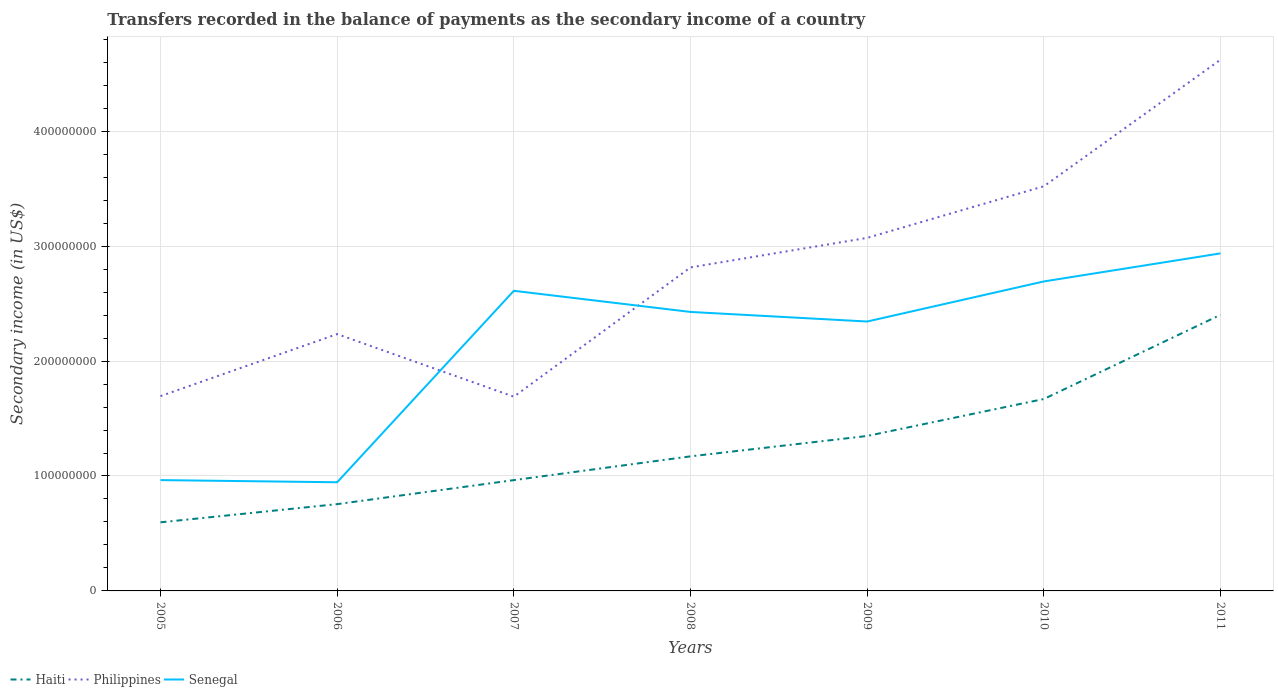Across all years, what is the maximum secondary income of in Senegal?
Give a very brief answer. 9.45e+07. What is the total secondary income of in Senegal in the graph?
Provide a short and direct response. -2.44e+07. What is the difference between the highest and the second highest secondary income of in Haiti?
Make the answer very short. 1.81e+08. What is the difference between the highest and the lowest secondary income of in Senegal?
Ensure brevity in your answer.  5. Is the secondary income of in Haiti strictly greater than the secondary income of in Senegal over the years?
Your response must be concise. Yes. How many years are there in the graph?
Give a very brief answer. 7. How many legend labels are there?
Make the answer very short. 3. How are the legend labels stacked?
Ensure brevity in your answer.  Horizontal. What is the title of the graph?
Provide a short and direct response. Transfers recorded in the balance of payments as the secondary income of a country. What is the label or title of the Y-axis?
Ensure brevity in your answer.  Secondary income (in US$). What is the Secondary income (in US$) in Haiti in 2005?
Make the answer very short. 5.97e+07. What is the Secondary income (in US$) of Philippines in 2005?
Provide a short and direct response. 1.69e+08. What is the Secondary income (in US$) in Senegal in 2005?
Provide a succinct answer. 9.64e+07. What is the Secondary income (in US$) of Haiti in 2006?
Offer a terse response. 7.55e+07. What is the Secondary income (in US$) of Philippines in 2006?
Make the answer very short. 2.23e+08. What is the Secondary income (in US$) of Senegal in 2006?
Give a very brief answer. 9.45e+07. What is the Secondary income (in US$) in Haiti in 2007?
Ensure brevity in your answer.  9.64e+07. What is the Secondary income (in US$) in Philippines in 2007?
Provide a succinct answer. 1.69e+08. What is the Secondary income (in US$) of Senegal in 2007?
Make the answer very short. 2.61e+08. What is the Secondary income (in US$) in Haiti in 2008?
Ensure brevity in your answer.  1.17e+08. What is the Secondary income (in US$) in Philippines in 2008?
Ensure brevity in your answer.  2.81e+08. What is the Secondary income (in US$) in Senegal in 2008?
Make the answer very short. 2.43e+08. What is the Secondary income (in US$) of Haiti in 2009?
Offer a very short reply. 1.35e+08. What is the Secondary income (in US$) of Philippines in 2009?
Provide a succinct answer. 3.07e+08. What is the Secondary income (in US$) of Senegal in 2009?
Provide a short and direct response. 2.34e+08. What is the Secondary income (in US$) of Haiti in 2010?
Provide a succinct answer. 1.67e+08. What is the Secondary income (in US$) in Philippines in 2010?
Your answer should be very brief. 3.52e+08. What is the Secondary income (in US$) of Senegal in 2010?
Provide a short and direct response. 2.69e+08. What is the Secondary income (in US$) in Haiti in 2011?
Offer a terse response. 2.40e+08. What is the Secondary income (in US$) in Philippines in 2011?
Your response must be concise. 4.62e+08. What is the Secondary income (in US$) of Senegal in 2011?
Your answer should be very brief. 2.94e+08. Across all years, what is the maximum Secondary income (in US$) of Haiti?
Your answer should be very brief. 2.40e+08. Across all years, what is the maximum Secondary income (in US$) of Philippines?
Your response must be concise. 4.62e+08. Across all years, what is the maximum Secondary income (in US$) of Senegal?
Make the answer very short. 2.94e+08. Across all years, what is the minimum Secondary income (in US$) of Haiti?
Provide a succinct answer. 5.97e+07. Across all years, what is the minimum Secondary income (in US$) of Philippines?
Your answer should be very brief. 1.69e+08. Across all years, what is the minimum Secondary income (in US$) in Senegal?
Give a very brief answer. 9.45e+07. What is the total Secondary income (in US$) of Haiti in the graph?
Give a very brief answer. 8.91e+08. What is the total Secondary income (in US$) in Philippines in the graph?
Ensure brevity in your answer.  1.96e+09. What is the total Secondary income (in US$) in Senegal in the graph?
Make the answer very short. 1.49e+09. What is the difference between the Secondary income (in US$) in Haiti in 2005 and that in 2006?
Your response must be concise. -1.58e+07. What is the difference between the Secondary income (in US$) in Philippines in 2005 and that in 2006?
Your answer should be very brief. -5.40e+07. What is the difference between the Secondary income (in US$) of Senegal in 2005 and that in 2006?
Give a very brief answer. 1.89e+06. What is the difference between the Secondary income (in US$) of Haiti in 2005 and that in 2007?
Make the answer very short. -3.67e+07. What is the difference between the Secondary income (in US$) of Philippines in 2005 and that in 2007?
Your answer should be very brief. 4.85e+05. What is the difference between the Secondary income (in US$) of Senegal in 2005 and that in 2007?
Offer a terse response. -1.65e+08. What is the difference between the Secondary income (in US$) in Haiti in 2005 and that in 2008?
Your response must be concise. -5.74e+07. What is the difference between the Secondary income (in US$) in Philippines in 2005 and that in 2008?
Offer a very short reply. -1.12e+08. What is the difference between the Secondary income (in US$) of Senegal in 2005 and that in 2008?
Offer a terse response. -1.46e+08. What is the difference between the Secondary income (in US$) in Haiti in 2005 and that in 2009?
Give a very brief answer. -7.51e+07. What is the difference between the Secondary income (in US$) of Philippines in 2005 and that in 2009?
Ensure brevity in your answer.  -1.38e+08. What is the difference between the Secondary income (in US$) of Senegal in 2005 and that in 2009?
Give a very brief answer. -1.38e+08. What is the difference between the Secondary income (in US$) in Haiti in 2005 and that in 2010?
Offer a very short reply. -1.07e+08. What is the difference between the Secondary income (in US$) of Philippines in 2005 and that in 2010?
Ensure brevity in your answer.  -1.83e+08. What is the difference between the Secondary income (in US$) in Senegal in 2005 and that in 2010?
Offer a very short reply. -1.73e+08. What is the difference between the Secondary income (in US$) in Haiti in 2005 and that in 2011?
Ensure brevity in your answer.  -1.81e+08. What is the difference between the Secondary income (in US$) of Philippines in 2005 and that in 2011?
Offer a very short reply. -2.93e+08. What is the difference between the Secondary income (in US$) of Senegal in 2005 and that in 2011?
Ensure brevity in your answer.  -1.97e+08. What is the difference between the Secondary income (in US$) of Haiti in 2006 and that in 2007?
Ensure brevity in your answer.  -2.09e+07. What is the difference between the Secondary income (in US$) of Philippines in 2006 and that in 2007?
Your response must be concise. 5.45e+07. What is the difference between the Secondary income (in US$) of Senegal in 2006 and that in 2007?
Your answer should be compact. -1.67e+08. What is the difference between the Secondary income (in US$) in Haiti in 2006 and that in 2008?
Offer a very short reply. -4.16e+07. What is the difference between the Secondary income (in US$) of Philippines in 2006 and that in 2008?
Your answer should be very brief. -5.80e+07. What is the difference between the Secondary income (in US$) of Senegal in 2006 and that in 2008?
Offer a very short reply. -1.48e+08. What is the difference between the Secondary income (in US$) in Haiti in 2006 and that in 2009?
Offer a very short reply. -5.93e+07. What is the difference between the Secondary income (in US$) of Philippines in 2006 and that in 2009?
Give a very brief answer. -8.37e+07. What is the difference between the Secondary income (in US$) of Senegal in 2006 and that in 2009?
Your response must be concise. -1.40e+08. What is the difference between the Secondary income (in US$) of Haiti in 2006 and that in 2010?
Give a very brief answer. -9.15e+07. What is the difference between the Secondary income (in US$) in Philippines in 2006 and that in 2010?
Your answer should be very brief. -1.29e+08. What is the difference between the Secondary income (in US$) of Senegal in 2006 and that in 2010?
Offer a very short reply. -1.75e+08. What is the difference between the Secondary income (in US$) in Haiti in 2006 and that in 2011?
Give a very brief answer. -1.65e+08. What is the difference between the Secondary income (in US$) in Philippines in 2006 and that in 2011?
Provide a succinct answer. -2.39e+08. What is the difference between the Secondary income (in US$) of Senegal in 2006 and that in 2011?
Your answer should be very brief. -1.99e+08. What is the difference between the Secondary income (in US$) of Haiti in 2007 and that in 2008?
Your response must be concise. -2.07e+07. What is the difference between the Secondary income (in US$) of Philippines in 2007 and that in 2008?
Ensure brevity in your answer.  -1.12e+08. What is the difference between the Secondary income (in US$) in Senegal in 2007 and that in 2008?
Provide a succinct answer. 1.84e+07. What is the difference between the Secondary income (in US$) of Haiti in 2007 and that in 2009?
Your response must be concise. -3.84e+07. What is the difference between the Secondary income (in US$) in Philippines in 2007 and that in 2009?
Keep it short and to the point. -1.38e+08. What is the difference between the Secondary income (in US$) of Senegal in 2007 and that in 2009?
Your response must be concise. 2.67e+07. What is the difference between the Secondary income (in US$) in Haiti in 2007 and that in 2010?
Offer a terse response. -7.06e+07. What is the difference between the Secondary income (in US$) of Philippines in 2007 and that in 2010?
Your answer should be very brief. -1.83e+08. What is the difference between the Secondary income (in US$) of Senegal in 2007 and that in 2010?
Offer a very short reply. -8.14e+06. What is the difference between the Secondary income (in US$) of Haiti in 2007 and that in 2011?
Ensure brevity in your answer.  -1.44e+08. What is the difference between the Secondary income (in US$) of Philippines in 2007 and that in 2011?
Your response must be concise. -2.93e+08. What is the difference between the Secondary income (in US$) in Senegal in 2007 and that in 2011?
Offer a terse response. -3.26e+07. What is the difference between the Secondary income (in US$) in Haiti in 2008 and that in 2009?
Your answer should be compact. -1.77e+07. What is the difference between the Secondary income (in US$) of Philippines in 2008 and that in 2009?
Provide a short and direct response. -2.57e+07. What is the difference between the Secondary income (in US$) of Senegal in 2008 and that in 2009?
Your response must be concise. 8.34e+06. What is the difference between the Secondary income (in US$) of Haiti in 2008 and that in 2010?
Ensure brevity in your answer.  -4.99e+07. What is the difference between the Secondary income (in US$) of Philippines in 2008 and that in 2010?
Give a very brief answer. -7.06e+07. What is the difference between the Secondary income (in US$) in Senegal in 2008 and that in 2010?
Your response must be concise. -2.65e+07. What is the difference between the Secondary income (in US$) of Haiti in 2008 and that in 2011?
Make the answer very short. -1.23e+08. What is the difference between the Secondary income (in US$) in Philippines in 2008 and that in 2011?
Offer a very short reply. -1.81e+08. What is the difference between the Secondary income (in US$) in Senegal in 2008 and that in 2011?
Provide a succinct answer. -5.10e+07. What is the difference between the Secondary income (in US$) in Haiti in 2009 and that in 2010?
Ensure brevity in your answer.  -3.22e+07. What is the difference between the Secondary income (in US$) of Philippines in 2009 and that in 2010?
Your answer should be very brief. -4.49e+07. What is the difference between the Secondary income (in US$) of Senegal in 2009 and that in 2010?
Make the answer very short. -3.49e+07. What is the difference between the Secondary income (in US$) in Haiti in 2009 and that in 2011?
Give a very brief answer. -1.05e+08. What is the difference between the Secondary income (in US$) in Philippines in 2009 and that in 2011?
Ensure brevity in your answer.  -1.55e+08. What is the difference between the Secondary income (in US$) of Senegal in 2009 and that in 2011?
Your answer should be very brief. -5.93e+07. What is the difference between the Secondary income (in US$) of Haiti in 2010 and that in 2011?
Your answer should be compact. -7.33e+07. What is the difference between the Secondary income (in US$) in Philippines in 2010 and that in 2011?
Ensure brevity in your answer.  -1.10e+08. What is the difference between the Secondary income (in US$) in Senegal in 2010 and that in 2011?
Offer a very short reply. -2.44e+07. What is the difference between the Secondary income (in US$) of Haiti in 2005 and the Secondary income (in US$) of Philippines in 2006?
Offer a terse response. -1.64e+08. What is the difference between the Secondary income (in US$) in Haiti in 2005 and the Secondary income (in US$) in Senegal in 2006?
Offer a terse response. -3.48e+07. What is the difference between the Secondary income (in US$) of Philippines in 2005 and the Secondary income (in US$) of Senegal in 2006?
Your answer should be compact. 7.50e+07. What is the difference between the Secondary income (in US$) in Haiti in 2005 and the Secondary income (in US$) in Philippines in 2007?
Ensure brevity in your answer.  -1.09e+08. What is the difference between the Secondary income (in US$) of Haiti in 2005 and the Secondary income (in US$) of Senegal in 2007?
Offer a terse response. -2.01e+08. What is the difference between the Secondary income (in US$) in Philippines in 2005 and the Secondary income (in US$) in Senegal in 2007?
Keep it short and to the point. -9.16e+07. What is the difference between the Secondary income (in US$) in Haiti in 2005 and the Secondary income (in US$) in Philippines in 2008?
Keep it short and to the point. -2.22e+08. What is the difference between the Secondary income (in US$) in Haiti in 2005 and the Secondary income (in US$) in Senegal in 2008?
Offer a terse response. -1.83e+08. What is the difference between the Secondary income (in US$) of Philippines in 2005 and the Secondary income (in US$) of Senegal in 2008?
Provide a short and direct response. -7.32e+07. What is the difference between the Secondary income (in US$) in Haiti in 2005 and the Secondary income (in US$) in Philippines in 2009?
Make the answer very short. -2.47e+08. What is the difference between the Secondary income (in US$) in Haiti in 2005 and the Secondary income (in US$) in Senegal in 2009?
Give a very brief answer. -1.75e+08. What is the difference between the Secondary income (in US$) in Philippines in 2005 and the Secondary income (in US$) in Senegal in 2009?
Give a very brief answer. -6.49e+07. What is the difference between the Secondary income (in US$) of Haiti in 2005 and the Secondary income (in US$) of Philippines in 2010?
Provide a short and direct response. -2.92e+08. What is the difference between the Secondary income (in US$) of Haiti in 2005 and the Secondary income (in US$) of Senegal in 2010?
Keep it short and to the point. -2.10e+08. What is the difference between the Secondary income (in US$) in Philippines in 2005 and the Secondary income (in US$) in Senegal in 2010?
Provide a short and direct response. -9.98e+07. What is the difference between the Secondary income (in US$) in Haiti in 2005 and the Secondary income (in US$) in Philippines in 2011?
Offer a very short reply. -4.03e+08. What is the difference between the Secondary income (in US$) in Haiti in 2005 and the Secondary income (in US$) in Senegal in 2011?
Your answer should be very brief. -2.34e+08. What is the difference between the Secondary income (in US$) of Philippines in 2005 and the Secondary income (in US$) of Senegal in 2011?
Ensure brevity in your answer.  -1.24e+08. What is the difference between the Secondary income (in US$) in Haiti in 2006 and the Secondary income (in US$) in Philippines in 2007?
Offer a terse response. -9.35e+07. What is the difference between the Secondary income (in US$) in Haiti in 2006 and the Secondary income (in US$) in Senegal in 2007?
Provide a succinct answer. -1.86e+08. What is the difference between the Secondary income (in US$) of Philippines in 2006 and the Secondary income (in US$) of Senegal in 2007?
Provide a short and direct response. -3.77e+07. What is the difference between the Secondary income (in US$) of Haiti in 2006 and the Secondary income (in US$) of Philippines in 2008?
Your answer should be compact. -2.06e+08. What is the difference between the Secondary income (in US$) of Haiti in 2006 and the Secondary income (in US$) of Senegal in 2008?
Give a very brief answer. -1.67e+08. What is the difference between the Secondary income (in US$) in Philippines in 2006 and the Secondary income (in US$) in Senegal in 2008?
Your answer should be compact. -1.93e+07. What is the difference between the Secondary income (in US$) of Haiti in 2006 and the Secondary income (in US$) of Philippines in 2009?
Ensure brevity in your answer.  -2.32e+08. What is the difference between the Secondary income (in US$) in Haiti in 2006 and the Secondary income (in US$) in Senegal in 2009?
Keep it short and to the point. -1.59e+08. What is the difference between the Secondary income (in US$) in Philippines in 2006 and the Secondary income (in US$) in Senegal in 2009?
Make the answer very short. -1.09e+07. What is the difference between the Secondary income (in US$) in Haiti in 2006 and the Secondary income (in US$) in Philippines in 2010?
Your response must be concise. -2.77e+08. What is the difference between the Secondary income (in US$) of Haiti in 2006 and the Secondary income (in US$) of Senegal in 2010?
Provide a short and direct response. -1.94e+08. What is the difference between the Secondary income (in US$) of Philippines in 2006 and the Secondary income (in US$) of Senegal in 2010?
Your answer should be compact. -4.58e+07. What is the difference between the Secondary income (in US$) in Haiti in 2006 and the Secondary income (in US$) in Philippines in 2011?
Your answer should be very brief. -3.87e+08. What is the difference between the Secondary income (in US$) in Haiti in 2006 and the Secondary income (in US$) in Senegal in 2011?
Offer a very short reply. -2.18e+08. What is the difference between the Secondary income (in US$) of Philippines in 2006 and the Secondary income (in US$) of Senegal in 2011?
Give a very brief answer. -7.02e+07. What is the difference between the Secondary income (in US$) of Haiti in 2007 and the Secondary income (in US$) of Philippines in 2008?
Keep it short and to the point. -1.85e+08. What is the difference between the Secondary income (in US$) of Haiti in 2007 and the Secondary income (in US$) of Senegal in 2008?
Provide a short and direct response. -1.46e+08. What is the difference between the Secondary income (in US$) of Philippines in 2007 and the Secondary income (in US$) of Senegal in 2008?
Your answer should be very brief. -7.37e+07. What is the difference between the Secondary income (in US$) of Haiti in 2007 and the Secondary income (in US$) of Philippines in 2009?
Ensure brevity in your answer.  -2.11e+08. What is the difference between the Secondary income (in US$) in Haiti in 2007 and the Secondary income (in US$) in Senegal in 2009?
Offer a very short reply. -1.38e+08. What is the difference between the Secondary income (in US$) in Philippines in 2007 and the Secondary income (in US$) in Senegal in 2009?
Provide a succinct answer. -6.54e+07. What is the difference between the Secondary income (in US$) in Haiti in 2007 and the Secondary income (in US$) in Philippines in 2010?
Ensure brevity in your answer.  -2.56e+08. What is the difference between the Secondary income (in US$) in Haiti in 2007 and the Secondary income (in US$) in Senegal in 2010?
Your response must be concise. -1.73e+08. What is the difference between the Secondary income (in US$) in Philippines in 2007 and the Secondary income (in US$) in Senegal in 2010?
Offer a very short reply. -1.00e+08. What is the difference between the Secondary income (in US$) of Haiti in 2007 and the Secondary income (in US$) of Philippines in 2011?
Offer a terse response. -3.66e+08. What is the difference between the Secondary income (in US$) of Haiti in 2007 and the Secondary income (in US$) of Senegal in 2011?
Keep it short and to the point. -1.97e+08. What is the difference between the Secondary income (in US$) of Philippines in 2007 and the Secondary income (in US$) of Senegal in 2011?
Ensure brevity in your answer.  -1.25e+08. What is the difference between the Secondary income (in US$) of Haiti in 2008 and the Secondary income (in US$) of Philippines in 2009?
Ensure brevity in your answer.  -1.90e+08. What is the difference between the Secondary income (in US$) of Haiti in 2008 and the Secondary income (in US$) of Senegal in 2009?
Your answer should be very brief. -1.17e+08. What is the difference between the Secondary income (in US$) of Philippines in 2008 and the Secondary income (in US$) of Senegal in 2009?
Keep it short and to the point. 4.71e+07. What is the difference between the Secondary income (in US$) of Haiti in 2008 and the Secondary income (in US$) of Philippines in 2010?
Provide a succinct answer. -2.35e+08. What is the difference between the Secondary income (in US$) of Haiti in 2008 and the Secondary income (in US$) of Senegal in 2010?
Your answer should be very brief. -1.52e+08. What is the difference between the Secondary income (in US$) in Philippines in 2008 and the Secondary income (in US$) in Senegal in 2010?
Your answer should be very brief. 1.22e+07. What is the difference between the Secondary income (in US$) of Haiti in 2008 and the Secondary income (in US$) of Philippines in 2011?
Your answer should be compact. -3.45e+08. What is the difference between the Secondary income (in US$) in Haiti in 2008 and the Secondary income (in US$) in Senegal in 2011?
Keep it short and to the point. -1.77e+08. What is the difference between the Secondary income (in US$) of Philippines in 2008 and the Secondary income (in US$) of Senegal in 2011?
Offer a very short reply. -1.22e+07. What is the difference between the Secondary income (in US$) in Haiti in 2009 and the Secondary income (in US$) in Philippines in 2010?
Provide a short and direct response. -2.17e+08. What is the difference between the Secondary income (in US$) of Haiti in 2009 and the Secondary income (in US$) of Senegal in 2010?
Provide a short and direct response. -1.34e+08. What is the difference between the Secondary income (in US$) of Philippines in 2009 and the Secondary income (in US$) of Senegal in 2010?
Offer a terse response. 3.79e+07. What is the difference between the Secondary income (in US$) in Haiti in 2009 and the Secondary income (in US$) in Philippines in 2011?
Offer a terse response. -3.27e+08. What is the difference between the Secondary income (in US$) of Haiti in 2009 and the Secondary income (in US$) of Senegal in 2011?
Give a very brief answer. -1.59e+08. What is the difference between the Secondary income (in US$) of Philippines in 2009 and the Secondary income (in US$) of Senegal in 2011?
Give a very brief answer. 1.35e+07. What is the difference between the Secondary income (in US$) in Haiti in 2010 and the Secondary income (in US$) in Philippines in 2011?
Provide a succinct answer. -2.95e+08. What is the difference between the Secondary income (in US$) in Haiti in 2010 and the Secondary income (in US$) in Senegal in 2011?
Your answer should be compact. -1.27e+08. What is the difference between the Secondary income (in US$) of Philippines in 2010 and the Secondary income (in US$) of Senegal in 2011?
Ensure brevity in your answer.  5.84e+07. What is the average Secondary income (in US$) in Haiti per year?
Offer a very short reply. 1.27e+08. What is the average Secondary income (in US$) of Philippines per year?
Your answer should be compact. 2.81e+08. What is the average Secondary income (in US$) in Senegal per year?
Provide a succinct answer. 2.13e+08. In the year 2005, what is the difference between the Secondary income (in US$) of Haiti and Secondary income (in US$) of Philippines?
Give a very brief answer. -1.10e+08. In the year 2005, what is the difference between the Secondary income (in US$) in Haiti and Secondary income (in US$) in Senegal?
Make the answer very short. -3.67e+07. In the year 2005, what is the difference between the Secondary income (in US$) in Philippines and Secondary income (in US$) in Senegal?
Your answer should be very brief. 7.31e+07. In the year 2006, what is the difference between the Secondary income (in US$) of Haiti and Secondary income (in US$) of Philippines?
Provide a succinct answer. -1.48e+08. In the year 2006, what is the difference between the Secondary income (in US$) in Haiti and Secondary income (in US$) in Senegal?
Your answer should be very brief. -1.90e+07. In the year 2006, what is the difference between the Secondary income (in US$) of Philippines and Secondary income (in US$) of Senegal?
Give a very brief answer. 1.29e+08. In the year 2007, what is the difference between the Secondary income (in US$) in Haiti and Secondary income (in US$) in Philippines?
Your answer should be compact. -7.26e+07. In the year 2007, what is the difference between the Secondary income (in US$) in Haiti and Secondary income (in US$) in Senegal?
Your answer should be compact. -1.65e+08. In the year 2007, what is the difference between the Secondary income (in US$) of Philippines and Secondary income (in US$) of Senegal?
Your response must be concise. -9.21e+07. In the year 2008, what is the difference between the Secondary income (in US$) of Haiti and Secondary income (in US$) of Philippines?
Ensure brevity in your answer.  -1.64e+08. In the year 2008, what is the difference between the Secondary income (in US$) of Haiti and Secondary income (in US$) of Senegal?
Make the answer very short. -1.26e+08. In the year 2008, what is the difference between the Secondary income (in US$) of Philippines and Secondary income (in US$) of Senegal?
Your response must be concise. 3.87e+07. In the year 2009, what is the difference between the Secondary income (in US$) of Haiti and Secondary income (in US$) of Philippines?
Your answer should be very brief. -1.72e+08. In the year 2009, what is the difference between the Secondary income (in US$) of Haiti and Secondary income (in US$) of Senegal?
Ensure brevity in your answer.  -9.96e+07. In the year 2009, what is the difference between the Secondary income (in US$) of Philippines and Secondary income (in US$) of Senegal?
Make the answer very short. 7.28e+07. In the year 2010, what is the difference between the Secondary income (in US$) of Haiti and Secondary income (in US$) of Philippines?
Provide a short and direct response. -1.85e+08. In the year 2010, what is the difference between the Secondary income (in US$) in Haiti and Secondary income (in US$) in Senegal?
Provide a short and direct response. -1.02e+08. In the year 2010, what is the difference between the Secondary income (in US$) in Philippines and Secondary income (in US$) in Senegal?
Give a very brief answer. 8.28e+07. In the year 2011, what is the difference between the Secondary income (in US$) in Haiti and Secondary income (in US$) in Philippines?
Provide a succinct answer. -2.22e+08. In the year 2011, what is the difference between the Secondary income (in US$) of Haiti and Secondary income (in US$) of Senegal?
Offer a terse response. -5.35e+07. In the year 2011, what is the difference between the Secondary income (in US$) in Philippines and Secondary income (in US$) in Senegal?
Offer a very short reply. 1.69e+08. What is the ratio of the Secondary income (in US$) of Haiti in 2005 to that in 2006?
Offer a terse response. 0.79. What is the ratio of the Secondary income (in US$) in Philippines in 2005 to that in 2006?
Give a very brief answer. 0.76. What is the ratio of the Secondary income (in US$) of Haiti in 2005 to that in 2007?
Ensure brevity in your answer.  0.62. What is the ratio of the Secondary income (in US$) in Senegal in 2005 to that in 2007?
Ensure brevity in your answer.  0.37. What is the ratio of the Secondary income (in US$) of Haiti in 2005 to that in 2008?
Provide a short and direct response. 0.51. What is the ratio of the Secondary income (in US$) of Philippines in 2005 to that in 2008?
Offer a very short reply. 0.6. What is the ratio of the Secondary income (in US$) of Senegal in 2005 to that in 2008?
Offer a very short reply. 0.4. What is the ratio of the Secondary income (in US$) in Haiti in 2005 to that in 2009?
Offer a terse response. 0.44. What is the ratio of the Secondary income (in US$) of Philippines in 2005 to that in 2009?
Your answer should be compact. 0.55. What is the ratio of the Secondary income (in US$) in Senegal in 2005 to that in 2009?
Give a very brief answer. 0.41. What is the ratio of the Secondary income (in US$) in Haiti in 2005 to that in 2010?
Offer a terse response. 0.36. What is the ratio of the Secondary income (in US$) of Philippines in 2005 to that in 2010?
Your answer should be compact. 0.48. What is the ratio of the Secondary income (in US$) of Senegal in 2005 to that in 2010?
Your response must be concise. 0.36. What is the ratio of the Secondary income (in US$) in Haiti in 2005 to that in 2011?
Your answer should be compact. 0.25. What is the ratio of the Secondary income (in US$) of Philippines in 2005 to that in 2011?
Your answer should be very brief. 0.37. What is the ratio of the Secondary income (in US$) in Senegal in 2005 to that in 2011?
Offer a terse response. 0.33. What is the ratio of the Secondary income (in US$) in Haiti in 2006 to that in 2007?
Offer a terse response. 0.78. What is the ratio of the Secondary income (in US$) in Philippines in 2006 to that in 2007?
Your answer should be compact. 1.32. What is the ratio of the Secondary income (in US$) of Senegal in 2006 to that in 2007?
Keep it short and to the point. 0.36. What is the ratio of the Secondary income (in US$) of Haiti in 2006 to that in 2008?
Provide a succinct answer. 0.65. What is the ratio of the Secondary income (in US$) of Philippines in 2006 to that in 2008?
Offer a terse response. 0.79. What is the ratio of the Secondary income (in US$) in Senegal in 2006 to that in 2008?
Give a very brief answer. 0.39. What is the ratio of the Secondary income (in US$) in Haiti in 2006 to that in 2009?
Make the answer very short. 0.56. What is the ratio of the Secondary income (in US$) in Philippines in 2006 to that in 2009?
Your response must be concise. 0.73. What is the ratio of the Secondary income (in US$) of Senegal in 2006 to that in 2009?
Ensure brevity in your answer.  0.4. What is the ratio of the Secondary income (in US$) in Haiti in 2006 to that in 2010?
Your answer should be compact. 0.45. What is the ratio of the Secondary income (in US$) of Philippines in 2006 to that in 2010?
Offer a very short reply. 0.63. What is the ratio of the Secondary income (in US$) in Senegal in 2006 to that in 2010?
Keep it short and to the point. 0.35. What is the ratio of the Secondary income (in US$) in Haiti in 2006 to that in 2011?
Make the answer very short. 0.31. What is the ratio of the Secondary income (in US$) in Philippines in 2006 to that in 2011?
Ensure brevity in your answer.  0.48. What is the ratio of the Secondary income (in US$) of Senegal in 2006 to that in 2011?
Offer a terse response. 0.32. What is the ratio of the Secondary income (in US$) in Haiti in 2007 to that in 2008?
Provide a succinct answer. 0.82. What is the ratio of the Secondary income (in US$) in Philippines in 2007 to that in 2008?
Provide a succinct answer. 0.6. What is the ratio of the Secondary income (in US$) in Senegal in 2007 to that in 2008?
Your answer should be very brief. 1.08. What is the ratio of the Secondary income (in US$) in Haiti in 2007 to that in 2009?
Give a very brief answer. 0.72. What is the ratio of the Secondary income (in US$) in Philippines in 2007 to that in 2009?
Provide a short and direct response. 0.55. What is the ratio of the Secondary income (in US$) in Senegal in 2007 to that in 2009?
Your response must be concise. 1.11. What is the ratio of the Secondary income (in US$) of Haiti in 2007 to that in 2010?
Provide a succinct answer. 0.58. What is the ratio of the Secondary income (in US$) of Philippines in 2007 to that in 2010?
Give a very brief answer. 0.48. What is the ratio of the Secondary income (in US$) of Senegal in 2007 to that in 2010?
Offer a very short reply. 0.97. What is the ratio of the Secondary income (in US$) of Haiti in 2007 to that in 2011?
Ensure brevity in your answer.  0.4. What is the ratio of the Secondary income (in US$) in Philippines in 2007 to that in 2011?
Provide a succinct answer. 0.37. What is the ratio of the Secondary income (in US$) in Senegal in 2007 to that in 2011?
Your answer should be compact. 0.89. What is the ratio of the Secondary income (in US$) in Haiti in 2008 to that in 2009?
Keep it short and to the point. 0.87. What is the ratio of the Secondary income (in US$) of Philippines in 2008 to that in 2009?
Give a very brief answer. 0.92. What is the ratio of the Secondary income (in US$) of Senegal in 2008 to that in 2009?
Provide a succinct answer. 1.04. What is the ratio of the Secondary income (in US$) in Haiti in 2008 to that in 2010?
Your answer should be compact. 0.7. What is the ratio of the Secondary income (in US$) in Philippines in 2008 to that in 2010?
Offer a very short reply. 0.8. What is the ratio of the Secondary income (in US$) in Senegal in 2008 to that in 2010?
Give a very brief answer. 0.9. What is the ratio of the Secondary income (in US$) of Haiti in 2008 to that in 2011?
Keep it short and to the point. 0.49. What is the ratio of the Secondary income (in US$) in Philippines in 2008 to that in 2011?
Provide a succinct answer. 0.61. What is the ratio of the Secondary income (in US$) in Senegal in 2008 to that in 2011?
Keep it short and to the point. 0.83. What is the ratio of the Secondary income (in US$) in Haiti in 2009 to that in 2010?
Provide a short and direct response. 0.81. What is the ratio of the Secondary income (in US$) of Philippines in 2009 to that in 2010?
Offer a very short reply. 0.87. What is the ratio of the Secondary income (in US$) in Senegal in 2009 to that in 2010?
Your response must be concise. 0.87. What is the ratio of the Secondary income (in US$) of Haiti in 2009 to that in 2011?
Your answer should be compact. 0.56. What is the ratio of the Secondary income (in US$) in Philippines in 2009 to that in 2011?
Your response must be concise. 0.66. What is the ratio of the Secondary income (in US$) of Senegal in 2009 to that in 2011?
Ensure brevity in your answer.  0.8. What is the ratio of the Secondary income (in US$) in Haiti in 2010 to that in 2011?
Keep it short and to the point. 0.7. What is the ratio of the Secondary income (in US$) in Philippines in 2010 to that in 2011?
Provide a short and direct response. 0.76. What is the ratio of the Secondary income (in US$) of Senegal in 2010 to that in 2011?
Your answer should be compact. 0.92. What is the difference between the highest and the second highest Secondary income (in US$) in Haiti?
Give a very brief answer. 7.33e+07. What is the difference between the highest and the second highest Secondary income (in US$) in Philippines?
Ensure brevity in your answer.  1.10e+08. What is the difference between the highest and the second highest Secondary income (in US$) in Senegal?
Keep it short and to the point. 2.44e+07. What is the difference between the highest and the lowest Secondary income (in US$) in Haiti?
Provide a short and direct response. 1.81e+08. What is the difference between the highest and the lowest Secondary income (in US$) in Philippines?
Offer a very short reply. 2.93e+08. What is the difference between the highest and the lowest Secondary income (in US$) in Senegal?
Ensure brevity in your answer.  1.99e+08. 